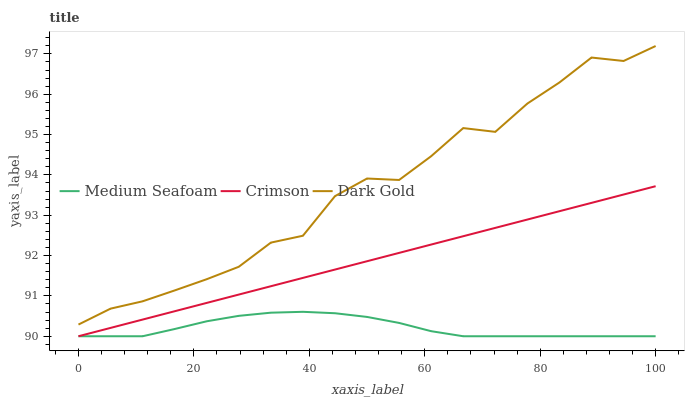Does Medium Seafoam have the minimum area under the curve?
Answer yes or no. Yes. Does Dark Gold have the maximum area under the curve?
Answer yes or no. Yes. Does Dark Gold have the minimum area under the curve?
Answer yes or no. No. Does Medium Seafoam have the maximum area under the curve?
Answer yes or no. No. Is Crimson the smoothest?
Answer yes or no. Yes. Is Dark Gold the roughest?
Answer yes or no. Yes. Is Medium Seafoam the smoothest?
Answer yes or no. No. Is Medium Seafoam the roughest?
Answer yes or no. No. Does Crimson have the lowest value?
Answer yes or no. Yes. Does Dark Gold have the lowest value?
Answer yes or no. No. Does Dark Gold have the highest value?
Answer yes or no. Yes. Does Medium Seafoam have the highest value?
Answer yes or no. No. Is Medium Seafoam less than Dark Gold?
Answer yes or no. Yes. Is Dark Gold greater than Crimson?
Answer yes or no. Yes. Does Medium Seafoam intersect Crimson?
Answer yes or no. Yes. Is Medium Seafoam less than Crimson?
Answer yes or no. No. Is Medium Seafoam greater than Crimson?
Answer yes or no. No. Does Medium Seafoam intersect Dark Gold?
Answer yes or no. No. 